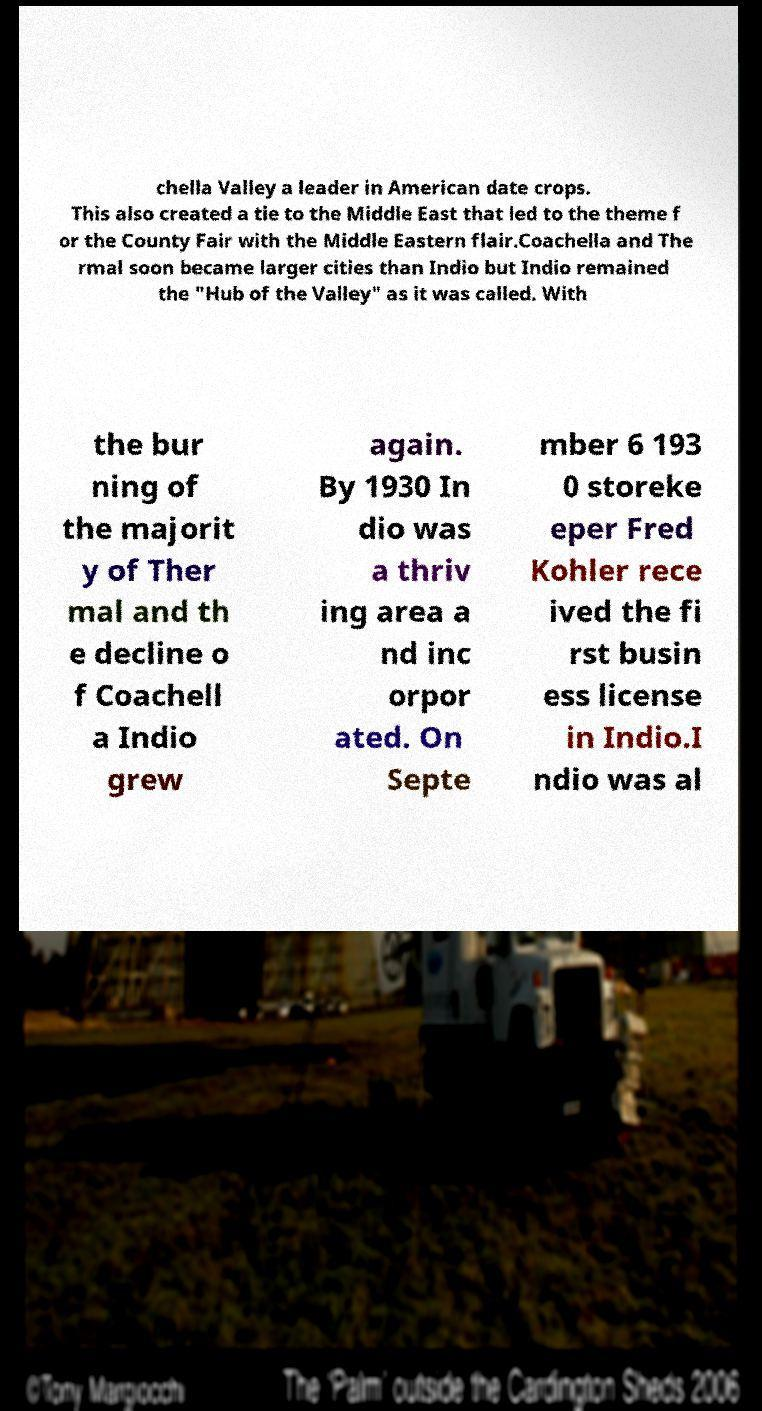Could you assist in decoding the text presented in this image and type it out clearly? chella Valley a leader in American date crops. This also created a tie to the Middle East that led to the theme f or the County Fair with the Middle Eastern flair.Coachella and The rmal soon became larger cities than Indio but Indio remained the "Hub of the Valley" as it was called. With the bur ning of the majorit y of Ther mal and th e decline o f Coachell a Indio grew again. By 1930 In dio was a thriv ing area a nd inc orpor ated. On Septe mber 6 193 0 storeke eper Fred Kohler rece ived the fi rst busin ess license in Indio.I ndio was al 